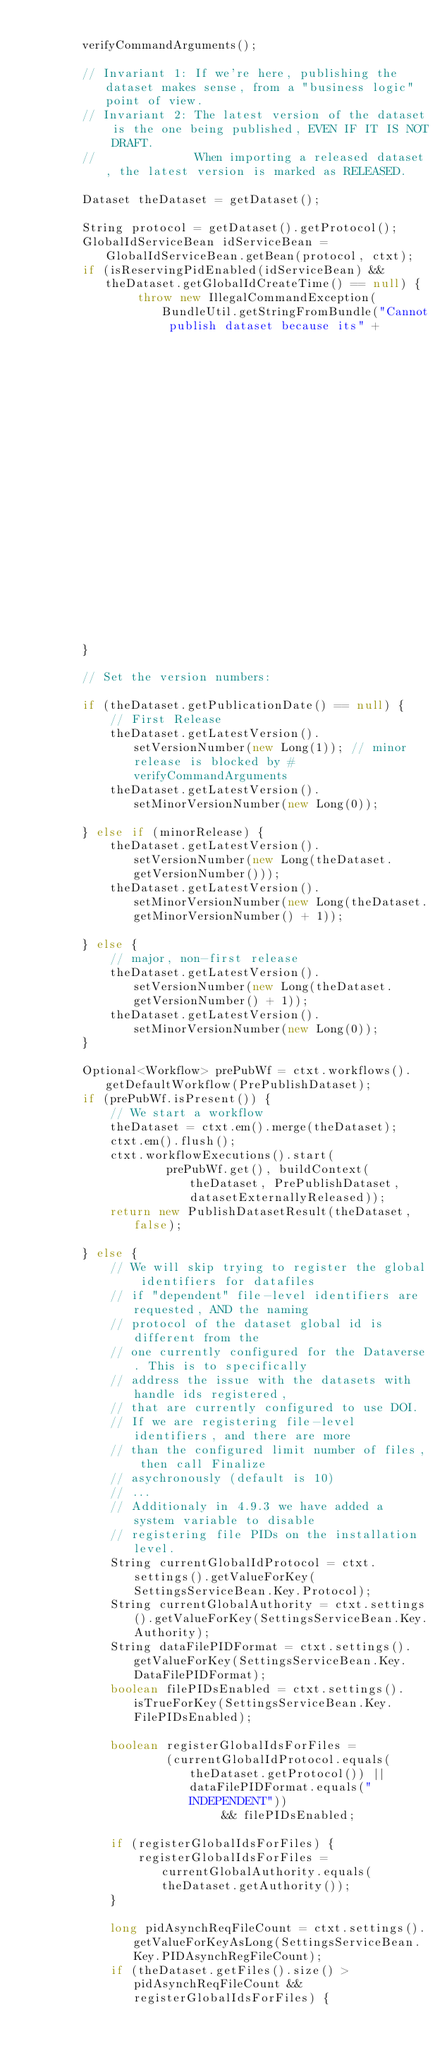<code> <loc_0><loc_0><loc_500><loc_500><_Java_>
        verifyCommandArguments();

        // Invariant 1: If we're here, publishing the dataset makes sense, from a "business logic" point of view.
        // Invariant 2: The latest version of the dataset is the one being published, EVEN IF IT IS NOT DRAFT.
        //              When importing a released dataset, the latest version is marked as RELEASED.

        Dataset theDataset = getDataset();

        String protocol = getDataset().getProtocol();
        GlobalIdServiceBean idServiceBean = GlobalIdServiceBean.getBean(protocol, ctxt);
        if (isReservingPidEnabled(idServiceBean) && theDataset.getGlobalIdCreateTime() == null) {
                throw new IllegalCommandException(BundleUtil.getStringFromBundle("Cannot publish dataset because its" +
                                                                                         " persistent identifier has not been reserved."), this);
        }

        // Set the version numbers:

        if (theDataset.getPublicationDate() == null) {
            // First Release
            theDataset.getLatestVersion().setVersionNumber(new Long(1)); // minor release is blocked by #verifyCommandArguments
            theDataset.getLatestVersion().setMinorVersionNumber(new Long(0));

        } else if (minorRelease) {
            theDataset.getLatestVersion().setVersionNumber(new Long(theDataset.getVersionNumber()));
            theDataset.getLatestVersion().setMinorVersionNumber(new Long(theDataset.getMinorVersionNumber() + 1));

        } else {
            // major, non-first release
            theDataset.getLatestVersion().setVersionNumber(new Long(theDataset.getVersionNumber() + 1));
            theDataset.getLatestVersion().setMinorVersionNumber(new Long(0));
        }

        Optional<Workflow> prePubWf = ctxt.workflows().getDefaultWorkflow(PrePublishDataset);
        if (prePubWf.isPresent()) {
            // We start a workflow
            theDataset = ctxt.em().merge(theDataset);
            ctxt.em().flush();
            ctxt.workflowExecutions().start(
                    prePubWf.get(), buildContext(theDataset, PrePublishDataset, datasetExternallyReleased));
            return new PublishDatasetResult(theDataset, false);

        } else {
            // We will skip trying to register the global identifiers for datafiles 
            // if "dependent" file-level identifiers are requested, AND the naming 
            // protocol of the dataset global id is different from the 
            // one currently configured for the Dataverse. This is to specifically 
            // address the issue with the datasets with handle ids registered, 
            // that are currently configured to use DOI.
            // If we are registering file-level identifiers, and there are more 
            // than the configured limit number of files, then call Finalize 
            // asychronously (default is 10)
            // ...
            // Additionaly in 4.9.3 we have added a system variable to disable 
            // registering file PIDs on the installation level.
            String currentGlobalIdProtocol = ctxt.settings().getValueForKey(SettingsServiceBean.Key.Protocol);
            String currentGlobalAuthority = ctxt.settings().getValueForKey(SettingsServiceBean.Key.Authority);
            String dataFilePIDFormat = ctxt.settings().getValueForKey(SettingsServiceBean.Key.DataFilePIDFormat);
            boolean filePIDsEnabled = ctxt.settings().isTrueForKey(SettingsServiceBean.Key.FilePIDsEnabled);

            boolean registerGlobalIdsForFiles =
                    (currentGlobalIdProtocol.equals(theDataset.getProtocol()) || dataFilePIDFormat.equals("INDEPENDENT"))
                            && filePIDsEnabled;

            if (registerGlobalIdsForFiles) {
                registerGlobalIdsForFiles = currentGlobalAuthority.equals(theDataset.getAuthority());
            }

            long pidAsynchReqFileCount = ctxt.settings().getValueForKeyAsLong(SettingsServiceBean.Key.PIDAsynchRegFileCount);
            if (theDataset.getFiles().size() > pidAsynchReqFileCount && registerGlobalIdsForFiles) {</code> 